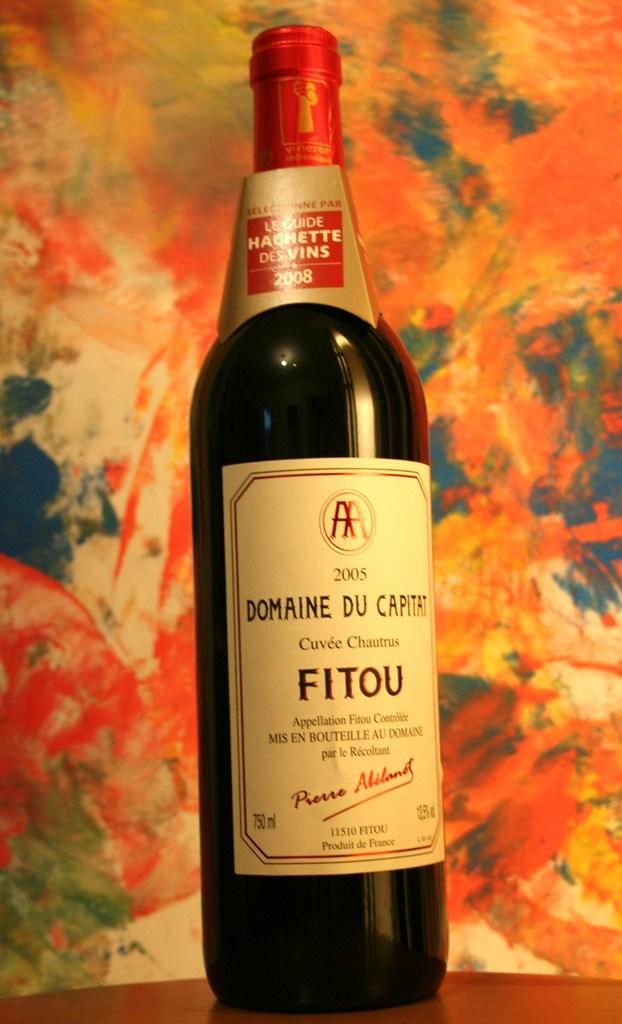What year was this beverage bottled?
Your answer should be compact. 2005. How many milliliters is this bottle?
Give a very brief answer. 750. 